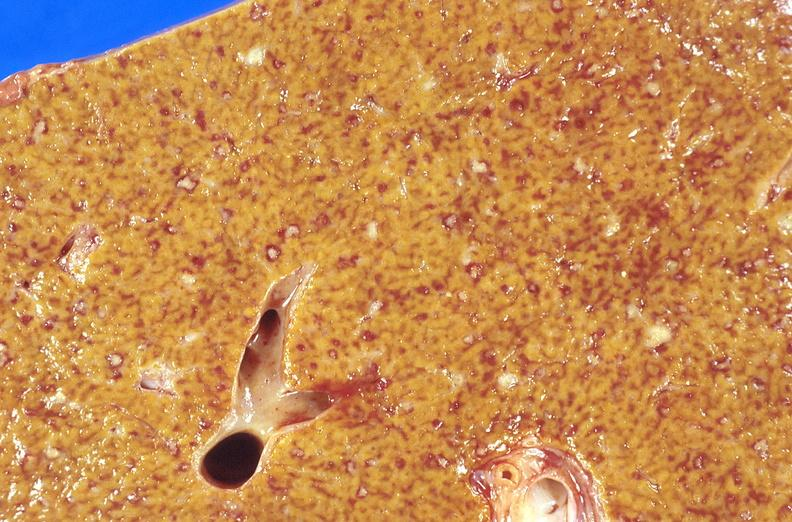does this image show liver, miliary tuberculosis?
Answer the question using a single word or phrase. Yes 